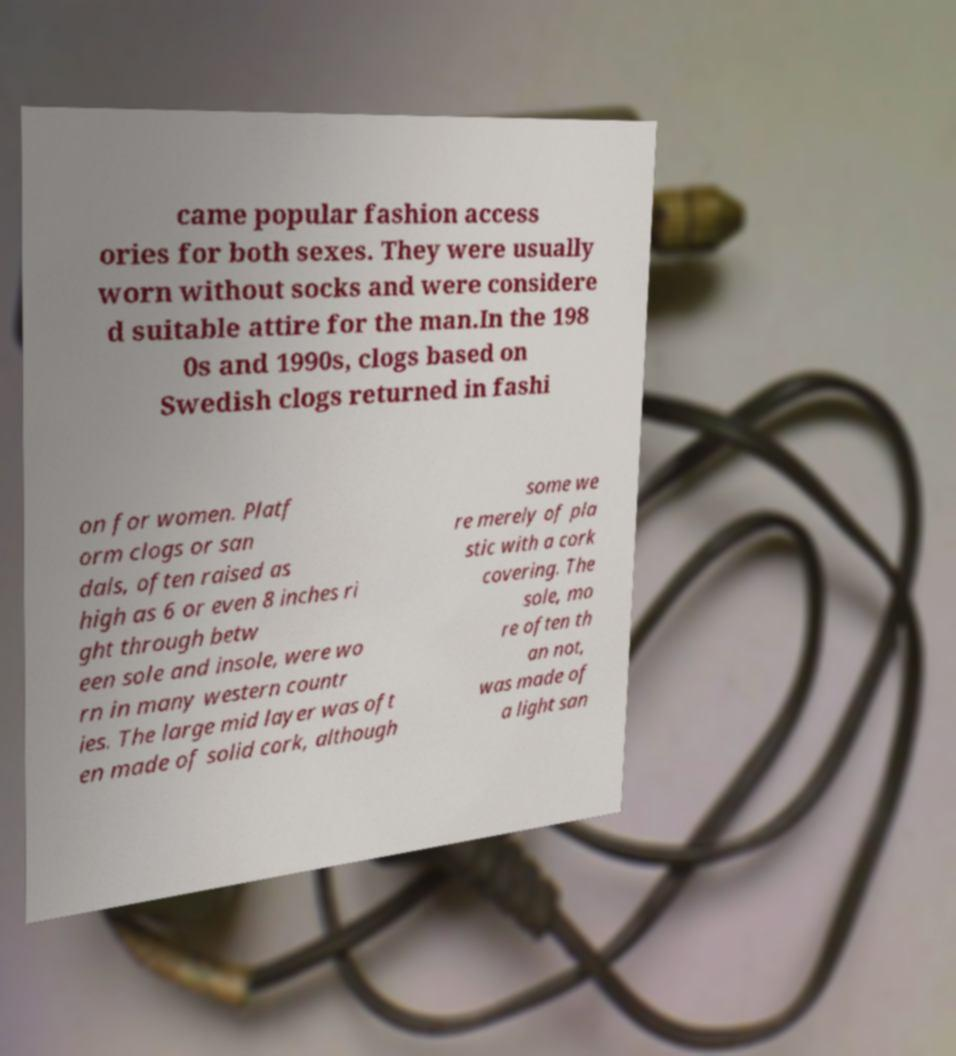There's text embedded in this image that I need extracted. Can you transcribe it verbatim? came popular fashion access ories for both sexes. They were usually worn without socks and were considere d suitable attire for the man.In the 198 0s and 1990s, clogs based on Swedish clogs returned in fashi on for women. Platf orm clogs or san dals, often raised as high as 6 or even 8 inches ri ght through betw een sole and insole, were wo rn in many western countr ies. The large mid layer was oft en made of solid cork, although some we re merely of pla stic with a cork covering. The sole, mo re often th an not, was made of a light san 